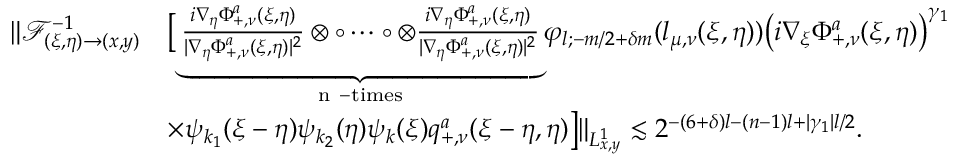Convert formula to latex. <formula><loc_0><loc_0><loc_500><loc_500>\begin{array} { r l } { \| \mathcal { F } _ { ( \xi , \eta ) \rightarrow ( x , y ) } ^ { - 1 } } & { \left [ \underbrace { \frac { i \nabla _ { \eta } \Phi _ { + , \nu } ^ { a } ( \xi , \eta ) } { | \nabla _ { \eta } \Phi _ { + , \nu } ^ { a } ( \xi , \eta ) | ^ { 2 } } \otimes \circ \cdots \circ \otimes \frac { i \nabla _ { \eta } \Phi _ { + , \nu } ^ { a } ( \xi , \eta ) } { | \nabla _ { \eta } \Phi _ { + , \nu } ^ { a } ( \xi , \eta ) | ^ { 2 } } } _ { n - t i m e s } \varphi _ { l ; - m / 2 + \delta m } ( l _ { \mu , \nu } ( \xi , \eta ) ) \left ( i \nabla _ { \xi } \Phi _ { + , \nu } ^ { a } ( \xi , \eta ) \right ) ^ { \gamma _ { 1 } } } \\ & { \times \psi _ { k _ { 1 } } ( \xi - \eta ) \psi _ { k _ { 2 } } ( \eta ) \psi _ { k } ( \xi ) q _ { + , \nu } ^ { a } ( \xi - \eta , \eta ) \right ] \| _ { L _ { x , y } ^ { 1 } } \lesssim 2 ^ { - ( 6 + \delta ) l - ( n - 1 ) l + | \gamma _ { 1 } | l / 2 } . } \end{array}</formula> 